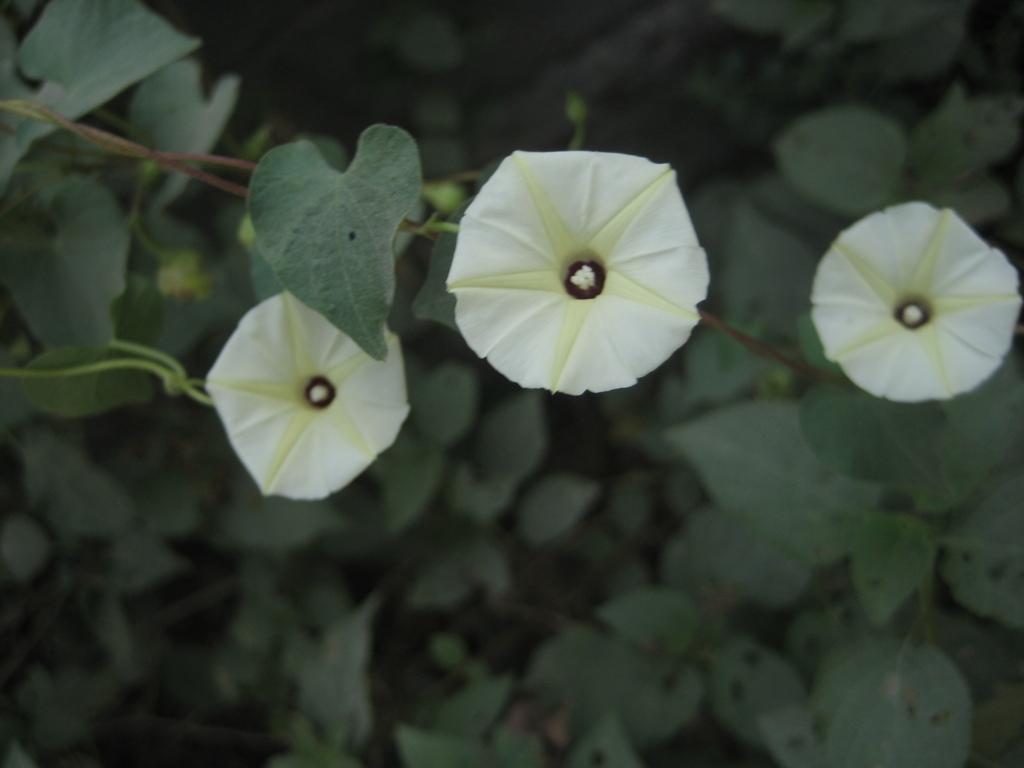Describe this image in one or two sentences. In this image we can see a group of plants and there are few flowers to the plants. 